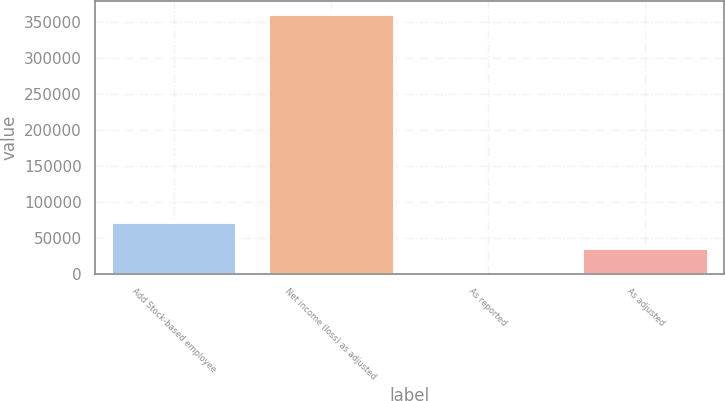Convert chart to OTSL. <chart><loc_0><loc_0><loc_500><loc_500><bar_chart><fcel>Add Stock-based employee<fcel>Net income (loss) as adjusted<fcel>As reported<fcel>As adjusted<nl><fcel>72057.3<fcel>360281<fcel>1.39<fcel>36029.3<nl></chart> 